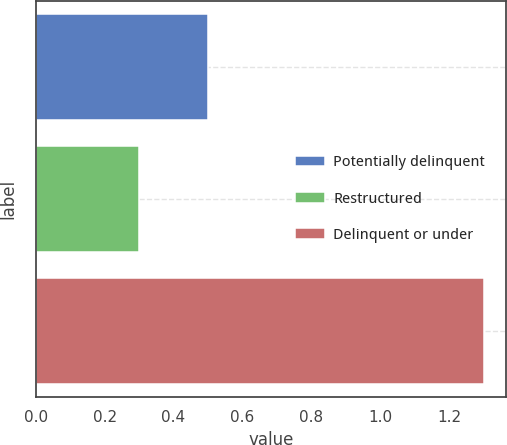Convert chart. <chart><loc_0><loc_0><loc_500><loc_500><bar_chart><fcel>Potentially delinquent<fcel>Restructured<fcel>Delinquent or under<nl><fcel>0.5<fcel>0.3<fcel>1.3<nl></chart> 